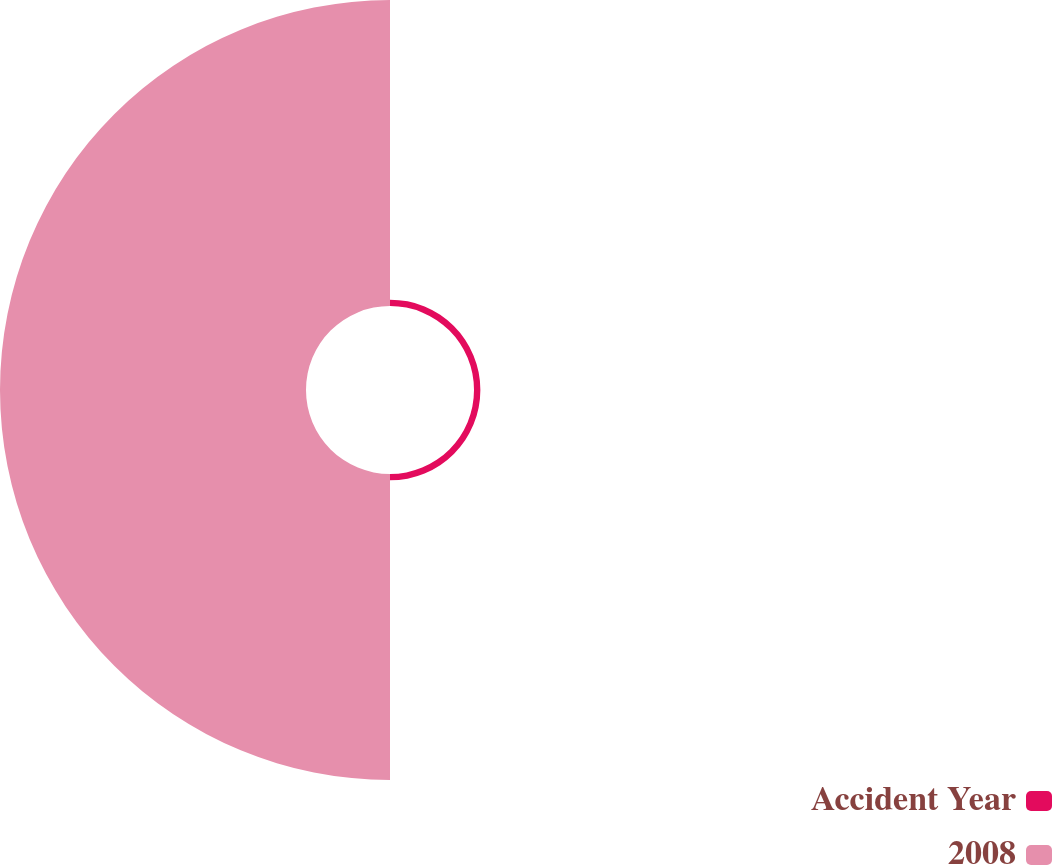<chart> <loc_0><loc_0><loc_500><loc_500><pie_chart><fcel>Accident Year<fcel>2008<nl><fcel>2.04%<fcel>97.96%<nl></chart> 